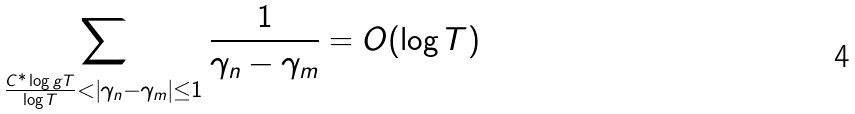<formula> <loc_0><loc_0><loc_500><loc_500>\sum _ { \frac { C ^ { * } \log g T } { \log T } < | \gamma _ { n } - \gamma _ { m } | \leq 1 } \frac { 1 } { \gamma _ { n } - \gamma _ { m } } = O ( \log T )</formula> 